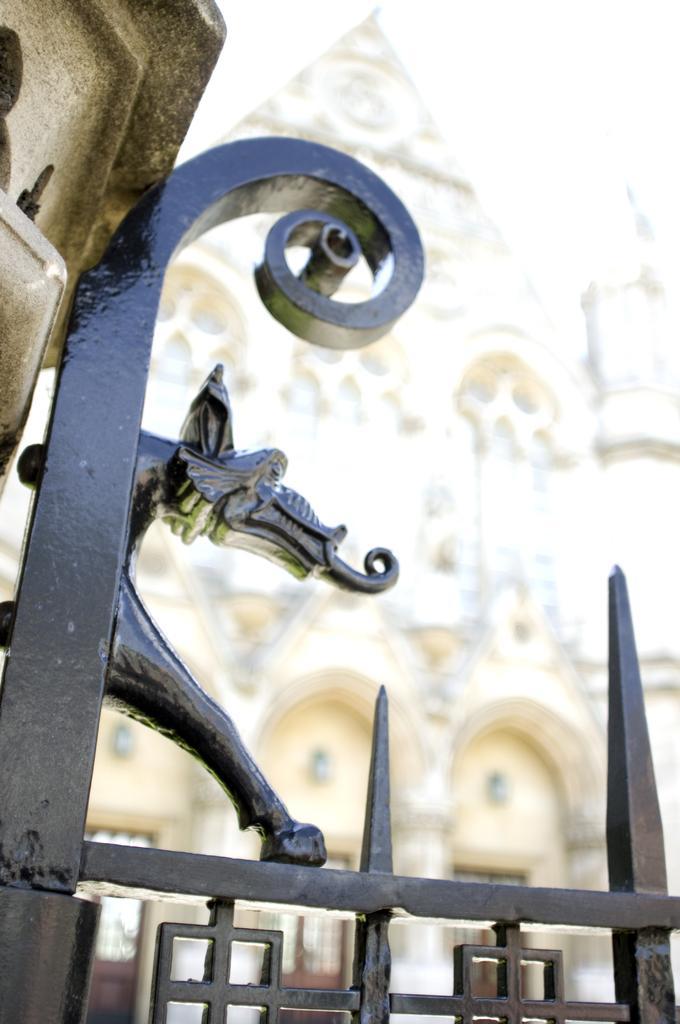Could you give a brief overview of what you see in this image? In this image we can see an iron grille. On the left side top of the image there is a wall. In the background of the image there is a building. 